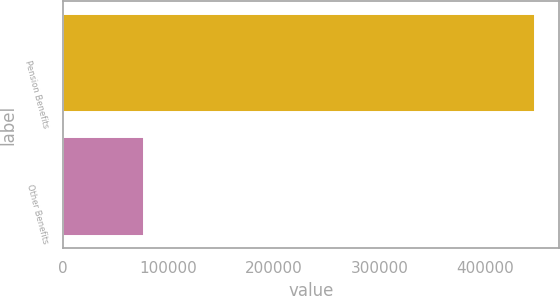<chart> <loc_0><loc_0><loc_500><loc_500><bar_chart><fcel>Pension Benefits<fcel>Other Benefits<nl><fcel>447262<fcel>76248<nl></chart> 